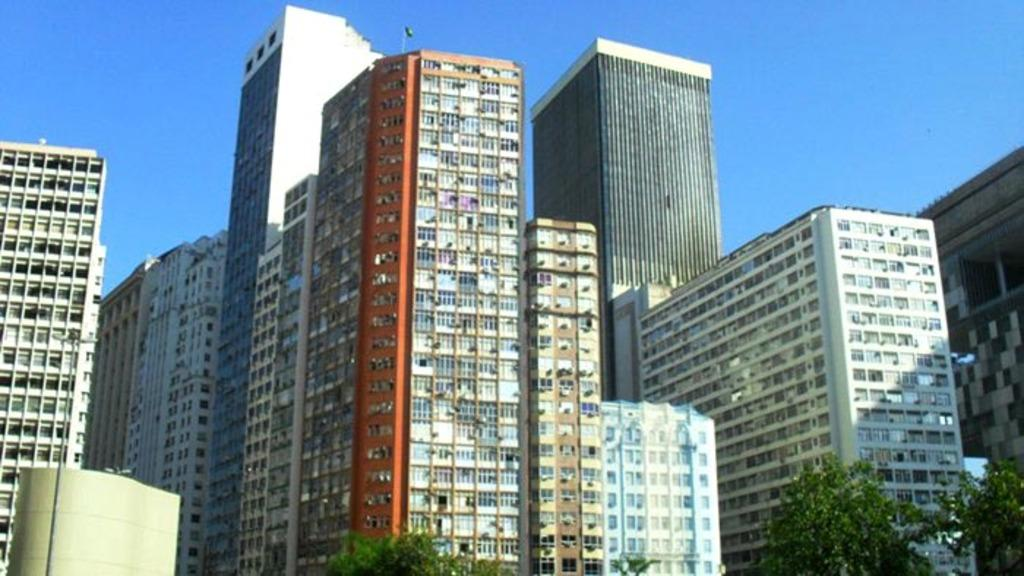What type of structures can be seen in the image? There are buildings in the image. What other natural elements are present in the image? There are trees in the image. What part of the natural environment is visible in the image? The sky is visible in the image. What type of noise can be heard coming from the zebra in the image? There is no zebra present in the image, so it is not possible to determine what, if any, noise might be heard. 